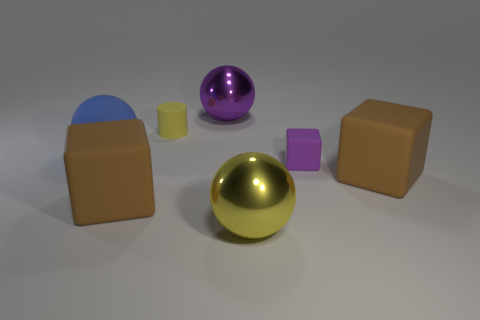What is the yellow object that is in front of the small matte object that is on the right side of the large yellow metallic sphere made of? metal 